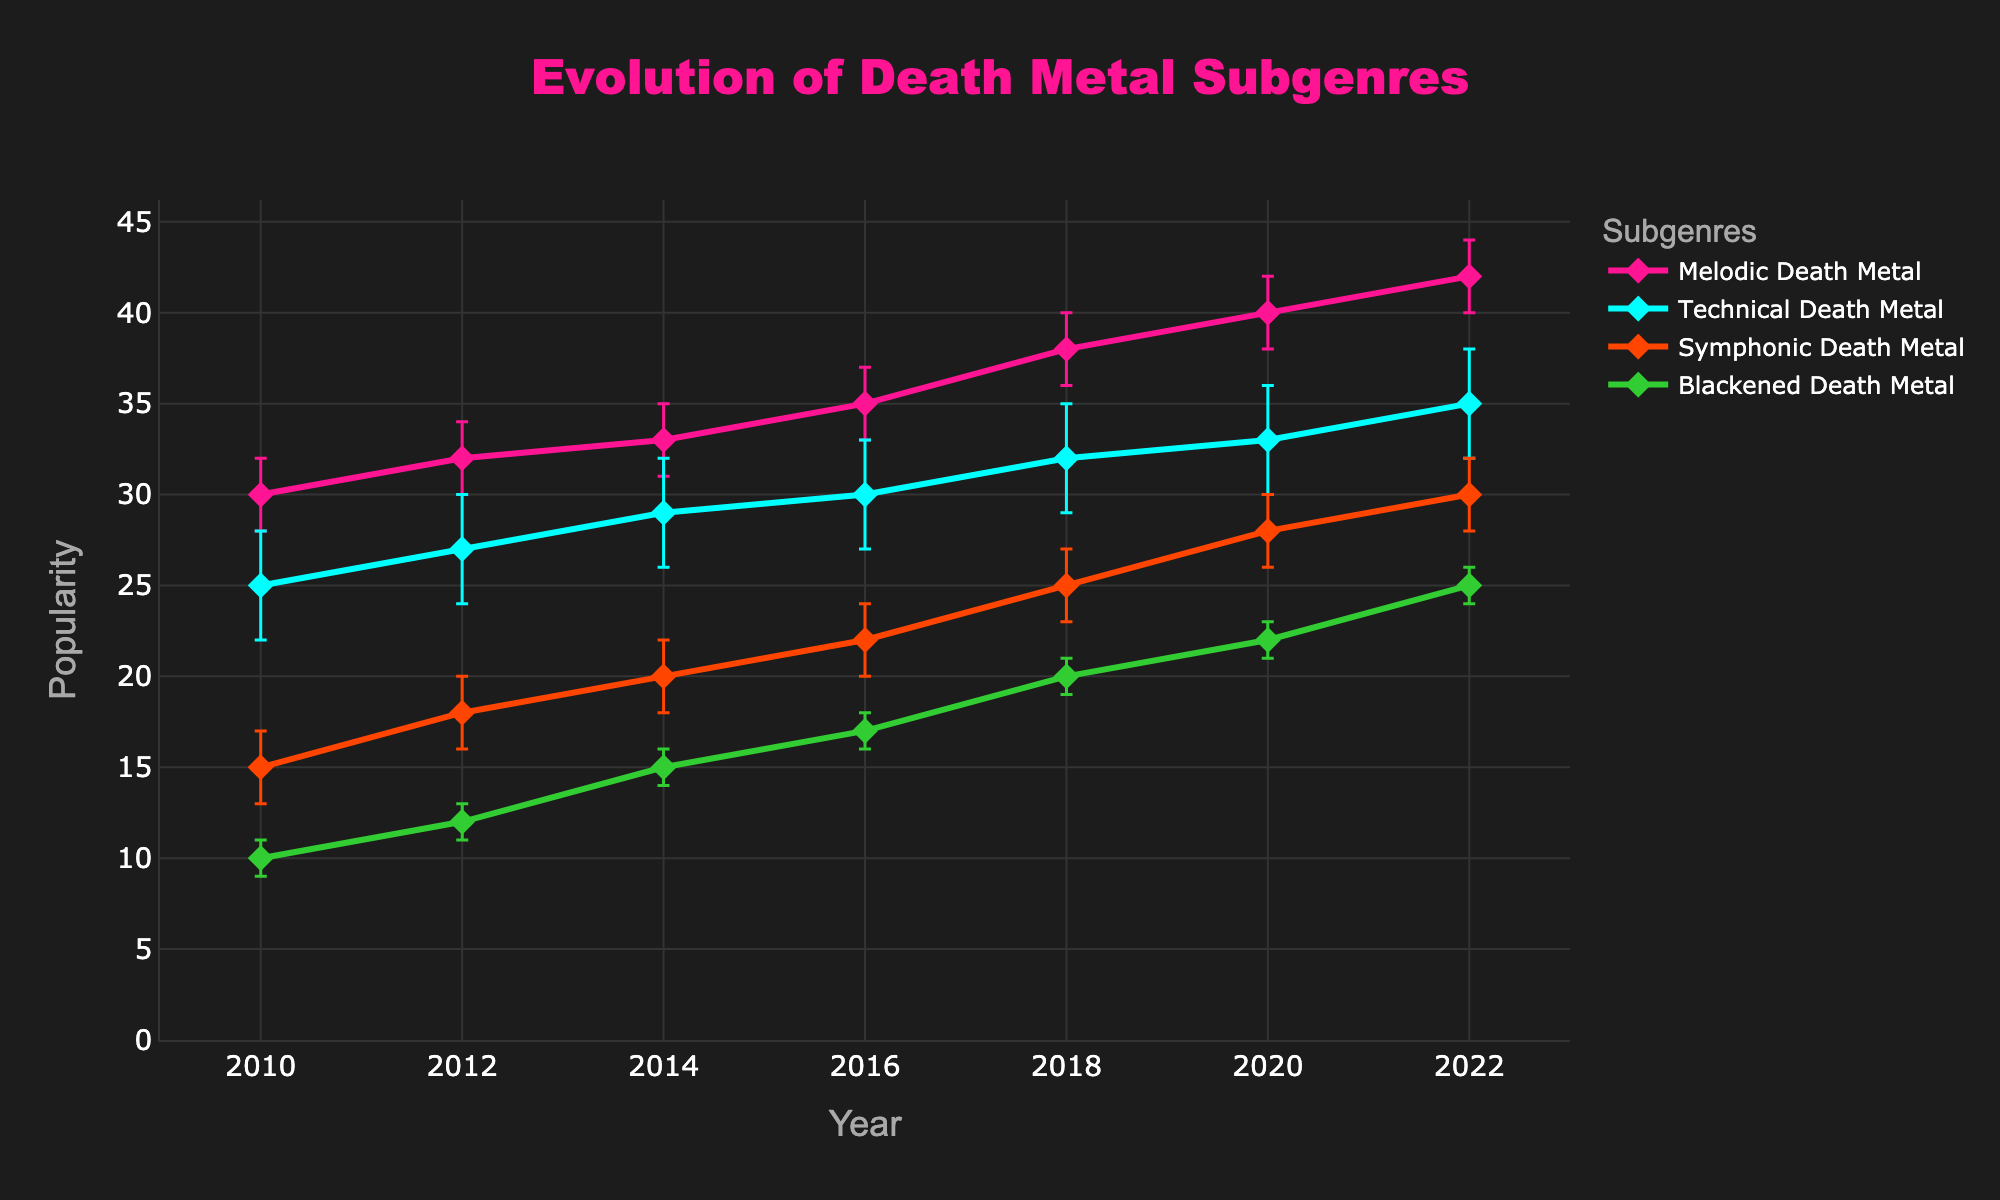What's the title of the figure? The title of the figure is usually placed at the top center and is larger and bolder compared to other text elements. In this case, it reads "Evolution of Death Metal Subgenres".
Answer: Evolution of Death Metal Subgenres What does the y-axis represent? The y-axis typically has a label indicating what it measures. Here, the y-axis represents "Popularity".
Answer: Popularity Which genre had the highest popularity in 2010? By looking at the data points for the year 2010, we can compare the popularity values. Melodic Death Metal has the highest popularity (30) for 2010.
Answer: Melodic Death Metal How has the popularity of Symphonic Death Metal changed from 2010 to 2022? By comparing the data points for Symphonic Death Metal from 2010 to 2022, we notice an increase from 15 to 30.
Answer: Increased In which year did Technical Death Metal first reach a popularity of 30? By following the data points for Technical Death Metal, we find that it first reaches a popularity of 30 in 2016.
Answer: 2016 How much did the popularity of Blackened Death Metal increase from 2010 to 2020? The popularity of Blackened Death Metal in 2010 was 10, and it increased to 22 in 2020. The increase is 22 - 10 = 12.
Answer: 12 Which subgenre shows the smallest margin of error in 2022? By looking at the error bars for 2022, Blackened Death Metal shows the smallest margin of error, which is 1.
Answer: Blackened Death Metal Compare the popularity trend of Melodic Death Metal and Technical Death Metal from 2010 to 2022. Which genre shows a steeper increase? Melodic Death Metal goes from 30 to 42 (an increase of 12), while Technical Death Metal goes from 25 to 35 (an increase of 10). Melodic Death Metal shows a steeper increase.
Answer: Melodic Death Metal What was the popularity of Symphonic Death Metal in the year 2014, including the margin of error? The popularity of Symphonic Death Metal in 2014 was 20 with a margin of error of ±2.
Answer: 20 ±2 